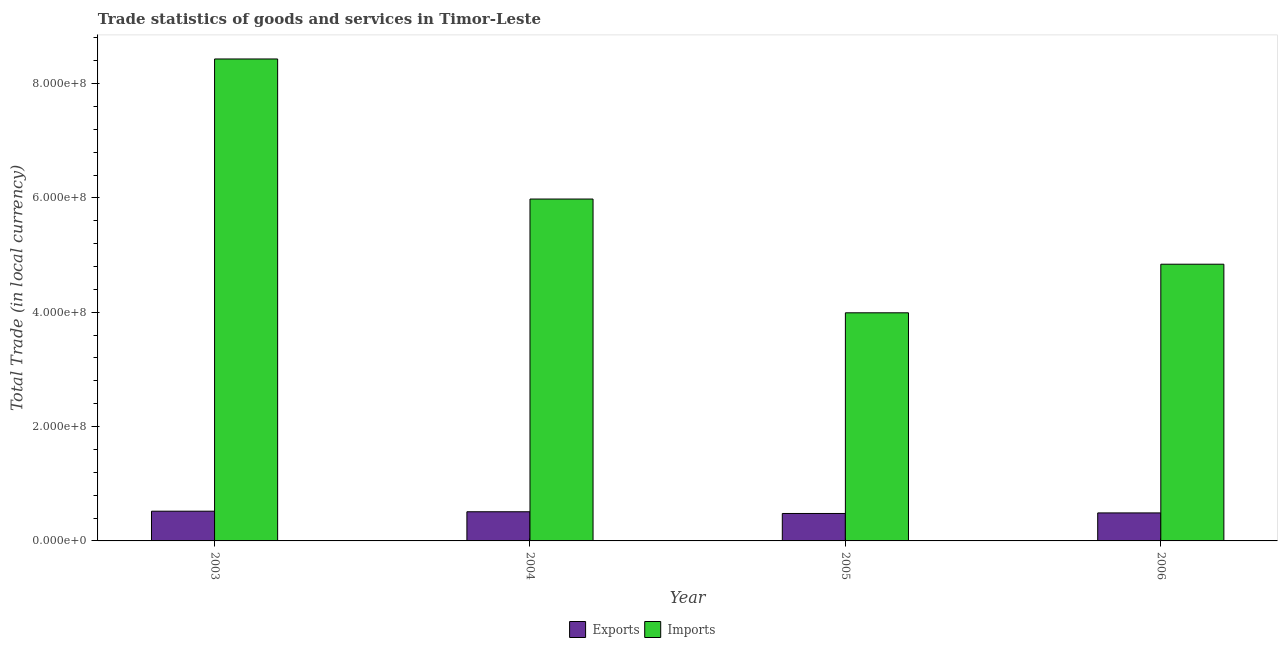How many different coloured bars are there?
Make the answer very short. 2. How many groups of bars are there?
Give a very brief answer. 4. Are the number of bars per tick equal to the number of legend labels?
Your answer should be very brief. Yes. Are the number of bars on each tick of the X-axis equal?
Keep it short and to the point. Yes. How many bars are there on the 1st tick from the left?
Provide a succinct answer. 2. What is the label of the 2nd group of bars from the left?
Your answer should be very brief. 2004. In how many cases, is the number of bars for a given year not equal to the number of legend labels?
Your answer should be very brief. 0. What is the export of goods and services in 2003?
Give a very brief answer. 5.20e+07. Across all years, what is the maximum export of goods and services?
Your answer should be very brief. 5.20e+07. Across all years, what is the minimum imports of goods and services?
Give a very brief answer. 3.99e+08. What is the total imports of goods and services in the graph?
Offer a terse response. 2.32e+09. What is the difference between the export of goods and services in 2004 and that in 2005?
Your response must be concise. 3.00e+06. What is the difference between the export of goods and services in 2005 and the imports of goods and services in 2003?
Ensure brevity in your answer.  -4.00e+06. What is the average imports of goods and services per year?
Ensure brevity in your answer.  5.81e+08. In how many years, is the imports of goods and services greater than 520000000 LCU?
Ensure brevity in your answer.  2. What is the ratio of the imports of goods and services in 2003 to that in 2006?
Your response must be concise. 1.74. Is the difference between the imports of goods and services in 2005 and 2006 greater than the difference between the export of goods and services in 2005 and 2006?
Your answer should be very brief. No. What is the difference between the highest and the second highest export of goods and services?
Make the answer very short. 1.00e+06. What is the difference between the highest and the lowest export of goods and services?
Give a very brief answer. 4.00e+06. In how many years, is the export of goods and services greater than the average export of goods and services taken over all years?
Keep it short and to the point. 2. Is the sum of the export of goods and services in 2003 and 2006 greater than the maximum imports of goods and services across all years?
Give a very brief answer. Yes. What does the 2nd bar from the left in 2005 represents?
Make the answer very short. Imports. What does the 1st bar from the right in 2004 represents?
Keep it short and to the point. Imports. Are all the bars in the graph horizontal?
Your answer should be compact. No. Does the graph contain any zero values?
Ensure brevity in your answer.  No. What is the title of the graph?
Provide a succinct answer. Trade statistics of goods and services in Timor-Leste. Does "Imports" appear as one of the legend labels in the graph?
Provide a short and direct response. Yes. What is the label or title of the Y-axis?
Provide a short and direct response. Total Trade (in local currency). What is the Total Trade (in local currency) in Exports in 2003?
Ensure brevity in your answer.  5.20e+07. What is the Total Trade (in local currency) in Imports in 2003?
Provide a succinct answer. 8.43e+08. What is the Total Trade (in local currency) in Exports in 2004?
Make the answer very short. 5.10e+07. What is the Total Trade (in local currency) of Imports in 2004?
Your response must be concise. 5.98e+08. What is the Total Trade (in local currency) in Exports in 2005?
Ensure brevity in your answer.  4.80e+07. What is the Total Trade (in local currency) in Imports in 2005?
Your response must be concise. 3.99e+08. What is the Total Trade (in local currency) in Exports in 2006?
Offer a very short reply. 4.90e+07. What is the Total Trade (in local currency) in Imports in 2006?
Your answer should be very brief. 4.84e+08. Across all years, what is the maximum Total Trade (in local currency) of Exports?
Your answer should be very brief. 5.20e+07. Across all years, what is the maximum Total Trade (in local currency) in Imports?
Provide a short and direct response. 8.43e+08. Across all years, what is the minimum Total Trade (in local currency) in Exports?
Your answer should be very brief. 4.80e+07. Across all years, what is the minimum Total Trade (in local currency) of Imports?
Ensure brevity in your answer.  3.99e+08. What is the total Total Trade (in local currency) of Imports in the graph?
Provide a succinct answer. 2.32e+09. What is the difference between the Total Trade (in local currency) of Imports in 2003 and that in 2004?
Make the answer very short. 2.45e+08. What is the difference between the Total Trade (in local currency) of Exports in 2003 and that in 2005?
Your answer should be compact. 4.00e+06. What is the difference between the Total Trade (in local currency) in Imports in 2003 and that in 2005?
Provide a succinct answer. 4.44e+08. What is the difference between the Total Trade (in local currency) in Imports in 2003 and that in 2006?
Your answer should be compact. 3.59e+08. What is the difference between the Total Trade (in local currency) of Imports in 2004 and that in 2005?
Provide a short and direct response. 1.99e+08. What is the difference between the Total Trade (in local currency) in Exports in 2004 and that in 2006?
Make the answer very short. 2.00e+06. What is the difference between the Total Trade (in local currency) of Imports in 2004 and that in 2006?
Offer a terse response. 1.14e+08. What is the difference between the Total Trade (in local currency) of Exports in 2005 and that in 2006?
Make the answer very short. -1.00e+06. What is the difference between the Total Trade (in local currency) of Imports in 2005 and that in 2006?
Ensure brevity in your answer.  -8.50e+07. What is the difference between the Total Trade (in local currency) in Exports in 2003 and the Total Trade (in local currency) in Imports in 2004?
Your response must be concise. -5.46e+08. What is the difference between the Total Trade (in local currency) of Exports in 2003 and the Total Trade (in local currency) of Imports in 2005?
Your answer should be compact. -3.47e+08. What is the difference between the Total Trade (in local currency) in Exports in 2003 and the Total Trade (in local currency) in Imports in 2006?
Give a very brief answer. -4.32e+08. What is the difference between the Total Trade (in local currency) of Exports in 2004 and the Total Trade (in local currency) of Imports in 2005?
Offer a very short reply. -3.48e+08. What is the difference between the Total Trade (in local currency) in Exports in 2004 and the Total Trade (in local currency) in Imports in 2006?
Provide a succinct answer. -4.33e+08. What is the difference between the Total Trade (in local currency) in Exports in 2005 and the Total Trade (in local currency) in Imports in 2006?
Make the answer very short. -4.36e+08. What is the average Total Trade (in local currency) of Exports per year?
Ensure brevity in your answer.  5.00e+07. What is the average Total Trade (in local currency) in Imports per year?
Offer a terse response. 5.81e+08. In the year 2003, what is the difference between the Total Trade (in local currency) of Exports and Total Trade (in local currency) of Imports?
Your answer should be compact. -7.91e+08. In the year 2004, what is the difference between the Total Trade (in local currency) of Exports and Total Trade (in local currency) of Imports?
Make the answer very short. -5.47e+08. In the year 2005, what is the difference between the Total Trade (in local currency) in Exports and Total Trade (in local currency) in Imports?
Ensure brevity in your answer.  -3.51e+08. In the year 2006, what is the difference between the Total Trade (in local currency) in Exports and Total Trade (in local currency) in Imports?
Keep it short and to the point. -4.35e+08. What is the ratio of the Total Trade (in local currency) of Exports in 2003 to that in 2004?
Provide a succinct answer. 1.02. What is the ratio of the Total Trade (in local currency) in Imports in 2003 to that in 2004?
Keep it short and to the point. 1.41. What is the ratio of the Total Trade (in local currency) in Exports in 2003 to that in 2005?
Provide a short and direct response. 1.08. What is the ratio of the Total Trade (in local currency) in Imports in 2003 to that in 2005?
Offer a very short reply. 2.11. What is the ratio of the Total Trade (in local currency) of Exports in 2003 to that in 2006?
Your response must be concise. 1.06. What is the ratio of the Total Trade (in local currency) of Imports in 2003 to that in 2006?
Provide a succinct answer. 1.74. What is the ratio of the Total Trade (in local currency) of Imports in 2004 to that in 2005?
Offer a very short reply. 1.5. What is the ratio of the Total Trade (in local currency) of Exports in 2004 to that in 2006?
Offer a terse response. 1.04. What is the ratio of the Total Trade (in local currency) in Imports in 2004 to that in 2006?
Offer a very short reply. 1.24. What is the ratio of the Total Trade (in local currency) in Exports in 2005 to that in 2006?
Provide a succinct answer. 0.98. What is the ratio of the Total Trade (in local currency) in Imports in 2005 to that in 2006?
Your answer should be compact. 0.82. What is the difference between the highest and the second highest Total Trade (in local currency) of Imports?
Make the answer very short. 2.45e+08. What is the difference between the highest and the lowest Total Trade (in local currency) in Imports?
Your response must be concise. 4.44e+08. 